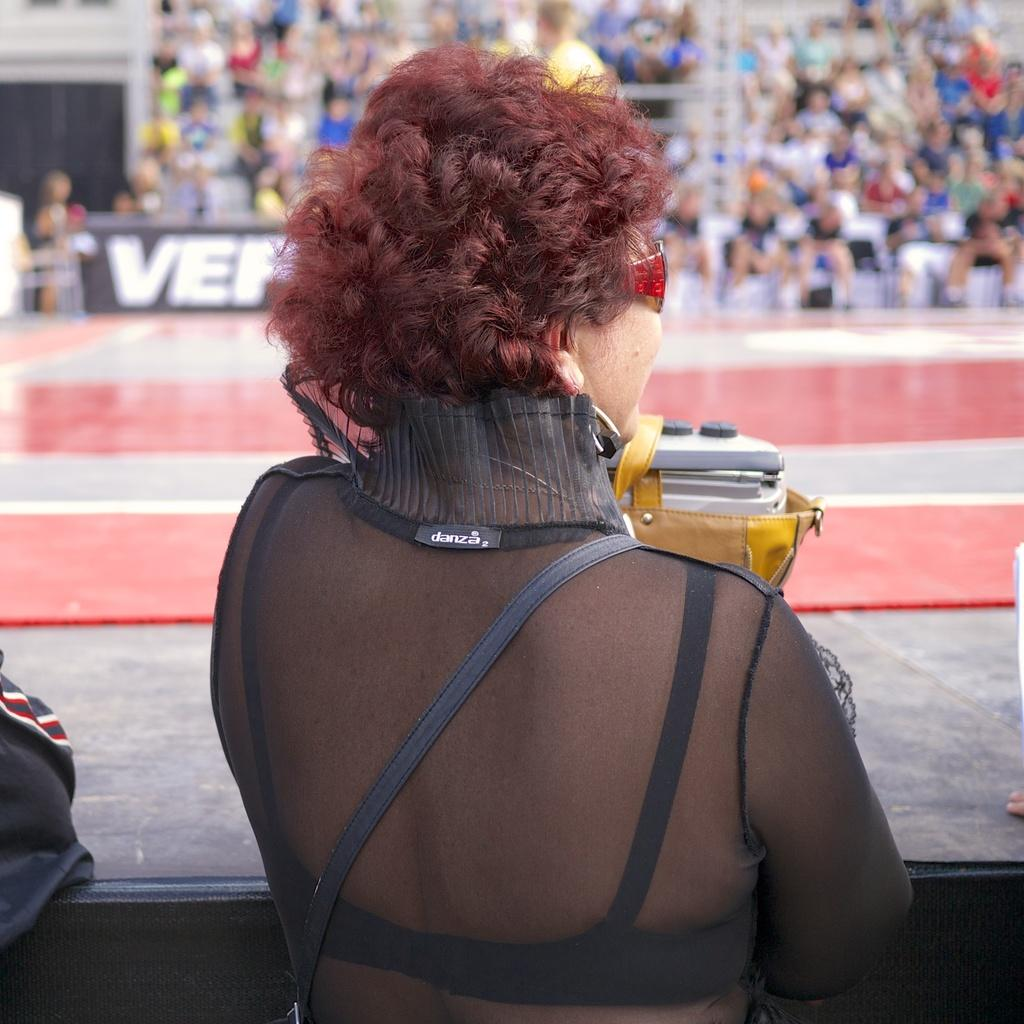Who is the main subject in the image? There is a woman in the image. What is the woman wearing that is unusual? The woman is wearing goggles. What can be seen in the background of the image? There are people sitting on chairs and a board with text in the background of the image. What type of orange is being used as a limit for the chicken in the image? There is no orange or chicken present in the image. 